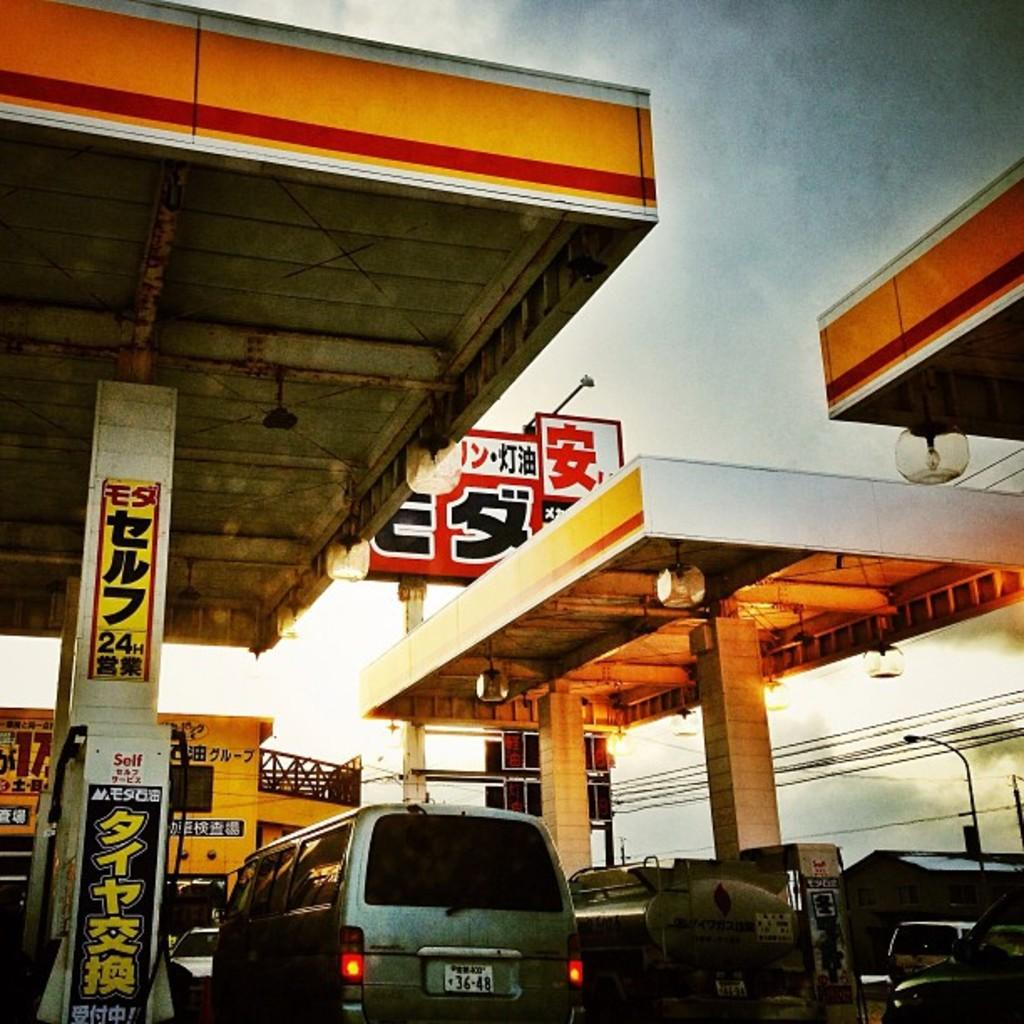What type of establishment is depicted in the image? There is a gas station in the image. What else can be seen in the image besides the gas station? There are vehicles and a building in the image. How would you describe the sky in the image? The sky is blue and cloudy in the image. What theory is being discussed by the pear in the image? There is no pear present in the image, and therefore no discussion or theory can be observed. 